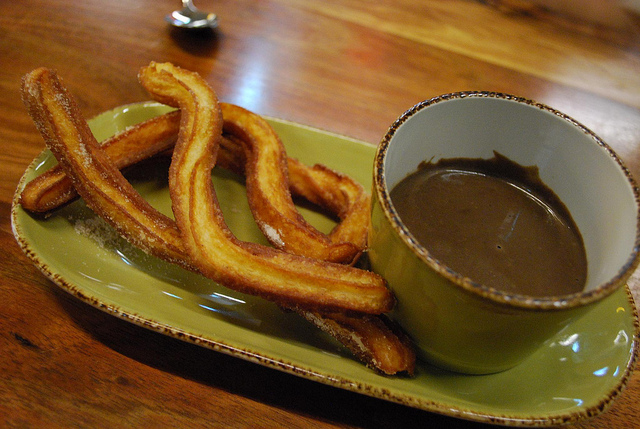What kind of food is in this scene? Churros are in this scene, paired perfectly with a cup of chocolate for dipping. 